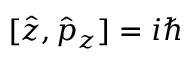Convert formula to latex. <formula><loc_0><loc_0><loc_500><loc_500>[ \hat { z } , \hat { p } _ { z } ] = i \hbar</formula> 